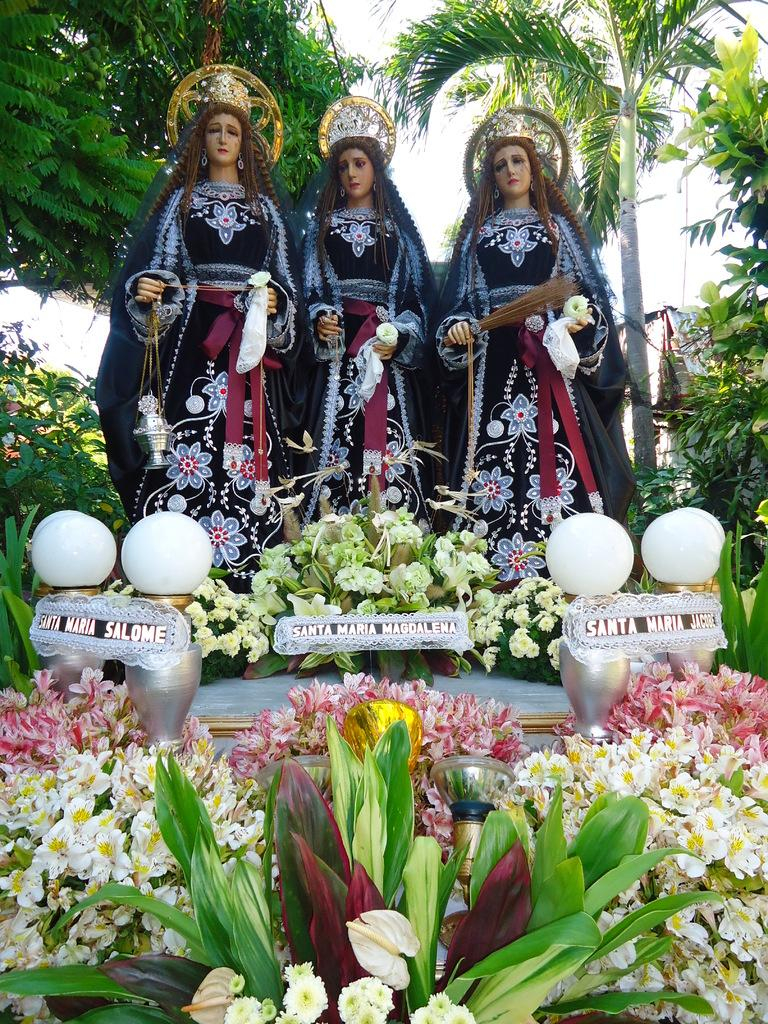What is the main theme of the image? The image depicts the status of women. What type of plants can be seen in the image? There are flower plants in the image. What color is predominant among the objects in the image? There are white color objects in the image. What can be seen in the background of the image? The sky is visible in the background of the image. How many drinks are being served by the servant in the image? There is no servant or drink present in the image. What type of crook is visible in the image? There is no crook present in the image. 